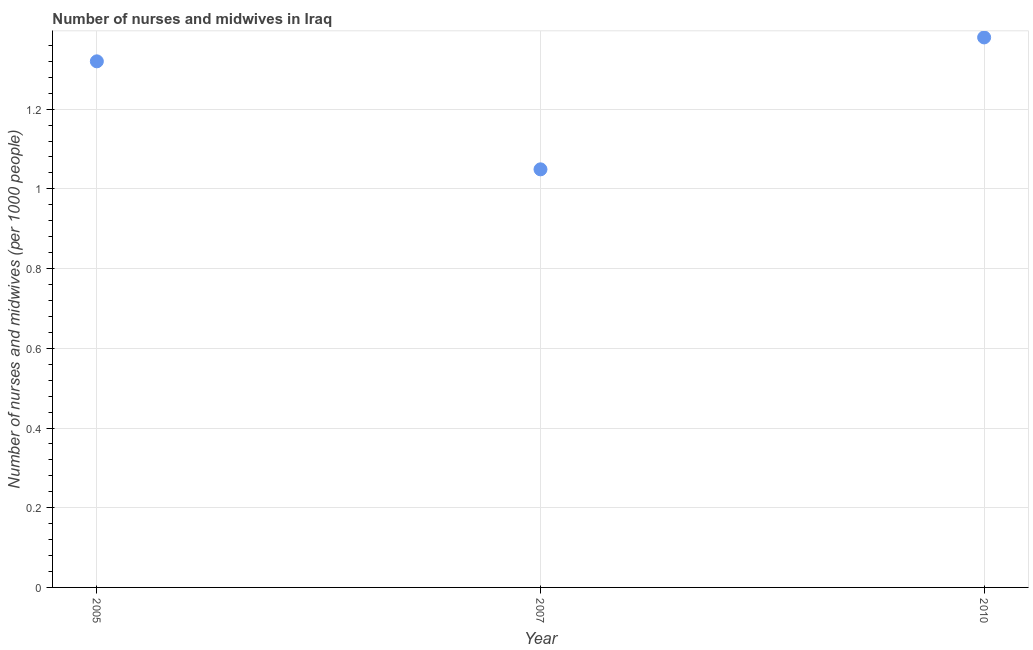What is the number of nurses and midwives in 2005?
Offer a terse response. 1.32. Across all years, what is the maximum number of nurses and midwives?
Keep it short and to the point. 1.38. Across all years, what is the minimum number of nurses and midwives?
Provide a short and direct response. 1.05. In which year was the number of nurses and midwives maximum?
Provide a short and direct response. 2010. What is the sum of the number of nurses and midwives?
Give a very brief answer. 3.75. What is the difference between the number of nurses and midwives in 2007 and 2010?
Offer a very short reply. -0.33. What is the average number of nurses and midwives per year?
Your answer should be compact. 1.25. What is the median number of nurses and midwives?
Your answer should be very brief. 1.32. Do a majority of the years between 2005 and 2010 (inclusive) have number of nurses and midwives greater than 1 ?
Your answer should be very brief. Yes. What is the ratio of the number of nurses and midwives in 2005 to that in 2010?
Ensure brevity in your answer.  0.96. Is the number of nurses and midwives in 2005 less than that in 2010?
Your answer should be compact. Yes. What is the difference between the highest and the second highest number of nurses and midwives?
Your answer should be very brief. 0.06. Is the sum of the number of nurses and midwives in 2005 and 2007 greater than the maximum number of nurses and midwives across all years?
Your answer should be very brief. Yes. What is the difference between the highest and the lowest number of nurses and midwives?
Your answer should be compact. 0.33. In how many years, is the number of nurses and midwives greater than the average number of nurses and midwives taken over all years?
Keep it short and to the point. 2. Does the number of nurses and midwives monotonically increase over the years?
Your answer should be very brief. No. What is the difference between two consecutive major ticks on the Y-axis?
Your answer should be compact. 0.2. Does the graph contain any zero values?
Your response must be concise. No. Does the graph contain grids?
Offer a terse response. Yes. What is the title of the graph?
Offer a terse response. Number of nurses and midwives in Iraq. What is the label or title of the X-axis?
Keep it short and to the point. Year. What is the label or title of the Y-axis?
Give a very brief answer. Number of nurses and midwives (per 1000 people). What is the Number of nurses and midwives (per 1000 people) in 2005?
Ensure brevity in your answer.  1.32. What is the Number of nurses and midwives (per 1000 people) in 2007?
Provide a short and direct response. 1.05. What is the Number of nurses and midwives (per 1000 people) in 2010?
Ensure brevity in your answer.  1.38. What is the difference between the Number of nurses and midwives (per 1000 people) in 2005 and 2007?
Provide a succinct answer. 0.27. What is the difference between the Number of nurses and midwives (per 1000 people) in 2005 and 2010?
Your answer should be compact. -0.06. What is the difference between the Number of nurses and midwives (per 1000 people) in 2007 and 2010?
Keep it short and to the point. -0.33. What is the ratio of the Number of nurses and midwives (per 1000 people) in 2005 to that in 2007?
Provide a succinct answer. 1.26. What is the ratio of the Number of nurses and midwives (per 1000 people) in 2005 to that in 2010?
Your answer should be compact. 0.96. What is the ratio of the Number of nurses and midwives (per 1000 people) in 2007 to that in 2010?
Ensure brevity in your answer.  0.76. 